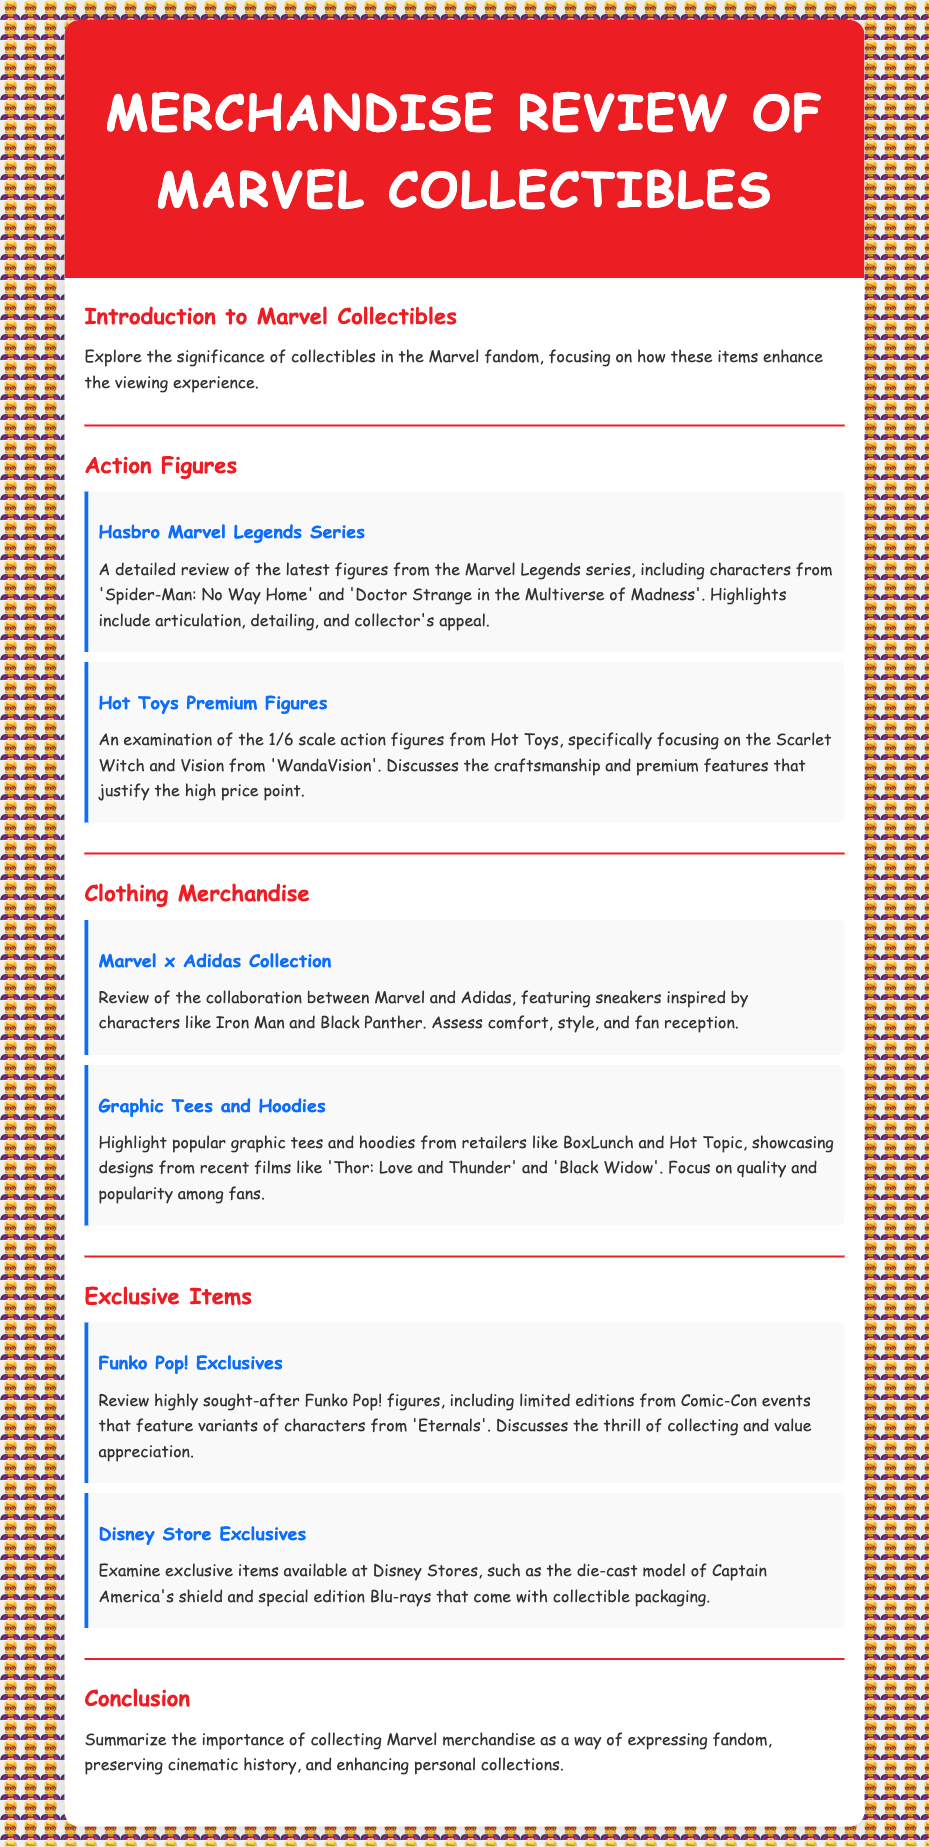What is the title of the document? The title of the document is displayed at the top of the page as "Merchandise Review of Marvel Collectibles."
Answer: Merchandise Review of Marvel Collectibles Who are two characters highlighted in Hasbro Marvel Legends Series? The document specifies two characters from the Marvel Legends Series, which are Spider-Man and Doctor Strange.
Answer: Spider-Man, Doctor Strange What company produced the Premium Figures? The document mentions Hot Toys as the company that produces the premium figures.
Answer: Hot Toys Which character is featured in the Funko Pop! Exclusives section? The document states that limited editions from Comic-Con events include variants of characters from Eternals.
Answer: Eternals What is the focus of the Marvel x Adidas Collection? The document focuses on sneakers inspired by characters like Iron Man and Black Panther.
Answer: Iron Man, Black Panther How many sections are there in the document? The document contains five main sections: Introduction, Action Figures, Clothing Merchandise, Exclusive Items, and Conclusion.
Answer: Five Which item is mentioned from Disney Store Exclusives? The document lists a die-cast model of Captain America's shield as an exclusive item.
Answer: Captain America's shield What theme do the clothing items in Graphic Tees and Hoodies generally represent? The document states that these clothing items showcase designs from recent films like Thor: Love and Thunder and Black Widow.
Answer: Recent films How is the importance of collecting Marvel merchandise summarized? The document summarizes that it allows expressing fandom, preserving cinematic history, and enhancing personal collections.
Answer: Expressing fandom, preserving cinematic history, enhancing personal collections 